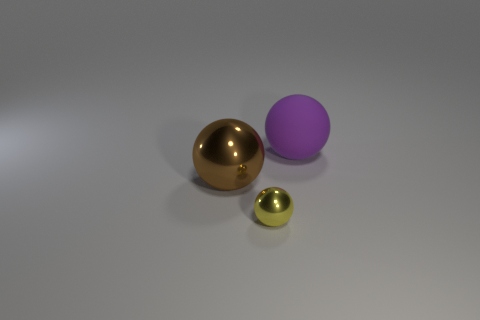How many big rubber objects have the same shape as the small shiny thing?
Give a very brief answer. 1. There is a thing that is on the right side of the object that is in front of the large thing on the left side of the yellow metallic thing; what is it made of?
Keep it short and to the point. Rubber. Are there any other small metal balls that have the same color as the small shiny ball?
Keep it short and to the point. No. Is the number of big brown balls that are left of the brown metal object less than the number of matte blocks?
Your answer should be compact. No. There is a purple rubber ball that is on the right side of the yellow thing; does it have the same size as the yellow sphere?
Provide a short and direct response. No. How many spheres are both in front of the large rubber sphere and behind the small yellow thing?
Your answer should be very brief. 1. There is a shiny sphere that is in front of the sphere that is left of the small yellow shiny object; how big is it?
Provide a succinct answer. Small. Is the number of yellow shiny objects that are left of the big shiny ball less than the number of things right of the small sphere?
Your response must be concise. Yes. There is a metal object that is left of the small yellow object; is it the same color as the large object that is on the right side of the small metallic sphere?
Provide a short and direct response. No. What is the material of the object that is left of the rubber object and behind the yellow sphere?
Your answer should be compact. Metal. 